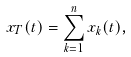<formula> <loc_0><loc_0><loc_500><loc_500>x _ { T } ( t ) = \sum _ { k = 1 } ^ { n } x _ { k } ( t ) ,</formula> 